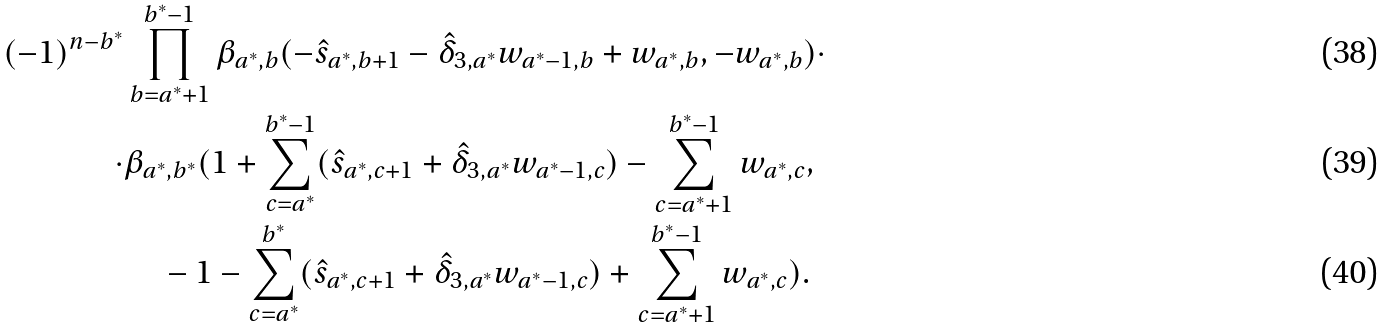<formula> <loc_0><loc_0><loc_500><loc_500>( - 1 ) ^ { n - b ^ { * } } & \prod _ { b = a ^ { * } + 1 } ^ { b ^ { * } - 1 } \beta _ { a ^ { * } , b } ( - \hat { s } _ { a ^ { * } , b + 1 } - \hat { \delta } _ { 3 , a ^ { * } } w _ { a ^ { * } - 1 , b } + w _ { a ^ { * } , b } , - w _ { a ^ { * } , b } ) \cdot \\ \cdot & \beta _ { a ^ { * } , b ^ { * } } ( 1 + \sum _ { c = a ^ { * } } ^ { b ^ { * } - 1 } ( \hat { s } _ { a ^ { * } , c + 1 } + \hat { \delta } _ { 3 , a ^ { * } } w _ { a ^ { * } - 1 , c } ) - \sum _ { c = a ^ { * } + 1 } ^ { b ^ { * } - 1 } w _ { a ^ { * } , c } , \\ & \quad - 1 - \sum _ { c = a ^ { * } } ^ { b ^ { * } } ( \hat { s } _ { a ^ { * } , c + 1 } + \hat { \delta } _ { 3 , a ^ { * } } w _ { a ^ { * } - 1 , c } ) + \sum _ { c = a ^ { * } + 1 } ^ { b ^ { * } - 1 } w _ { a ^ { * } , c } ) .</formula> 